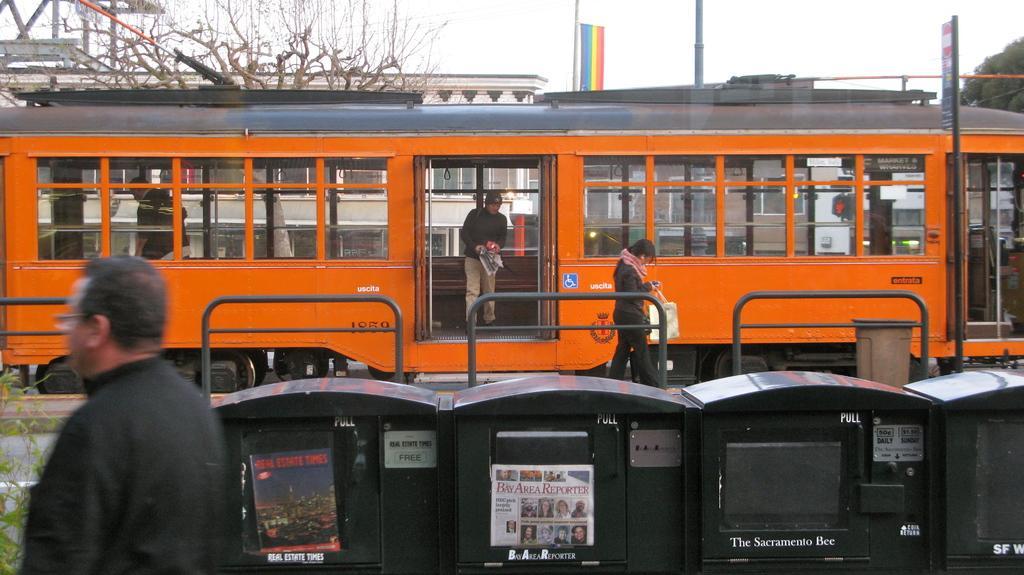How would you summarize this image in a sentence or two? In the picture I can see people, a train on the railway, trees, fence and some other objects on the ground. In the background I can see the sky, banner, and some other objects. 